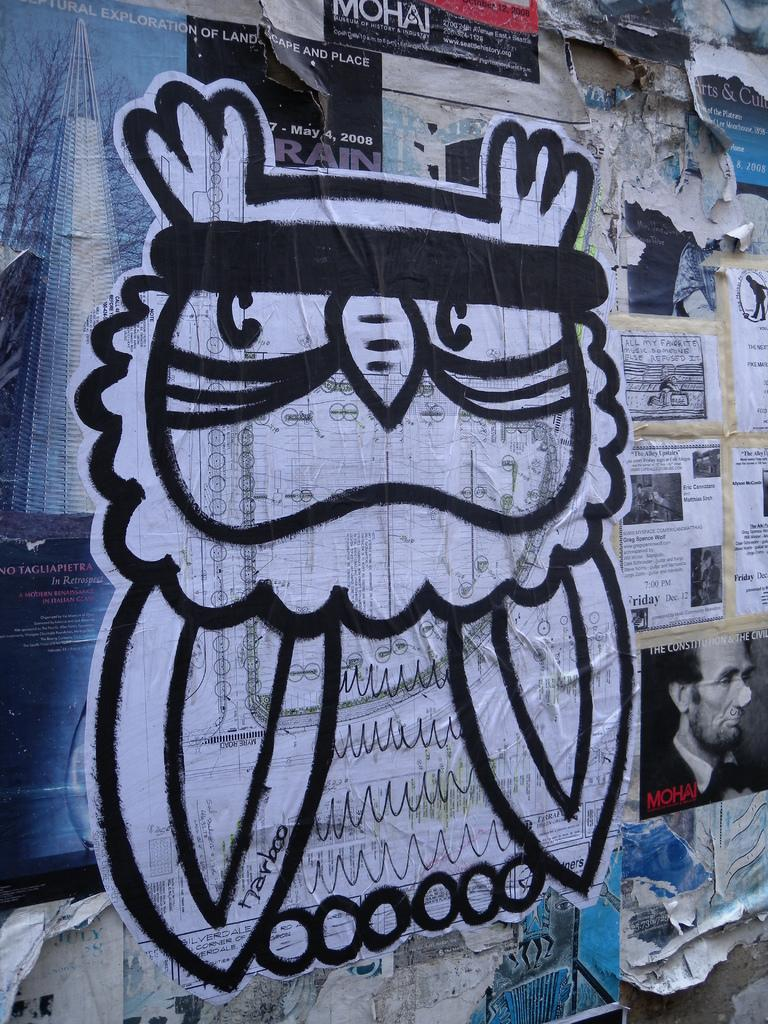What is present on the wall in the image? There are papers pasted on the wall. Can you describe the content of the papers on the wall? One of the papers depicts a man. What else can be seen in the image besides the wall and papers? There is no other information provided about the image. What type of pan is being used to cook in the image? There is no pan or cooking activity present in the image. Can you tell me how many chess pieces are visible on the wall? There is no mention of chess or chess pieces in the image. 